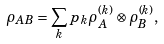<formula> <loc_0><loc_0><loc_500><loc_500>\rho _ { A B } = \sum _ { k } p _ { k } \rho _ { A } ^ { ( k ) } \otimes \rho _ { B } ^ { ( k ) } ,</formula> 